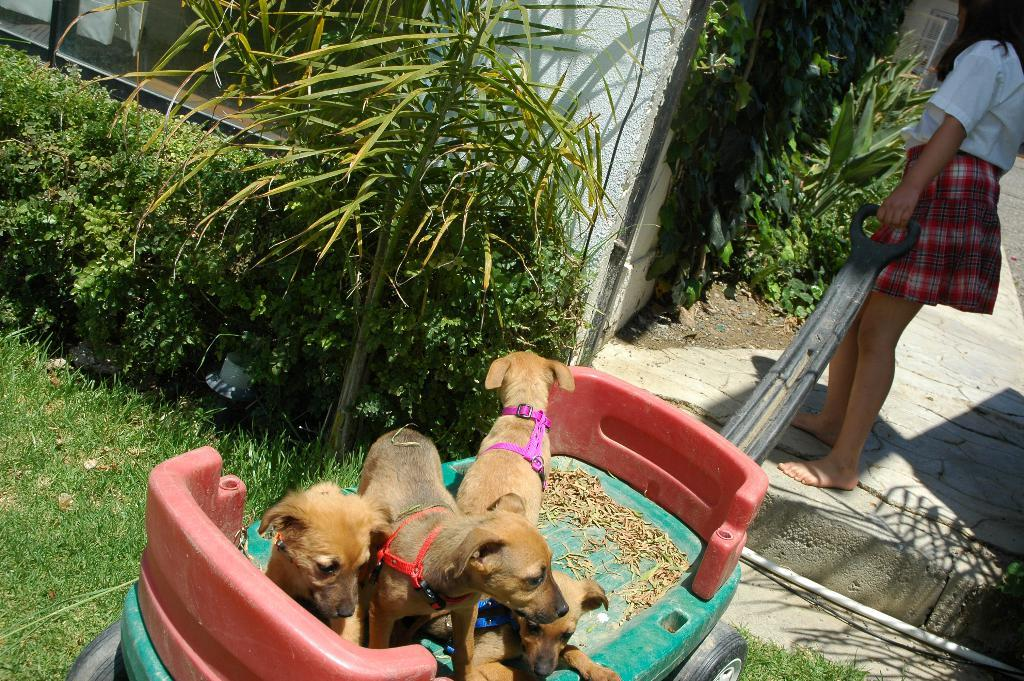What animals are on the cart in the image? There are dogs on a cart in the image. Who is holding the cart in the image? There is a woman holding the cart in the image. What type of terrain is visible in the image? There is grass visible in the image. What other vegetation can be seen in the image? There are plants in the image. What type of structure is present in the image? There is a wall in the image. What type of rhythm is the woman using to pull the cart in the image? There is no indication of rhythm in the image; the woman is simply holding the cart. 